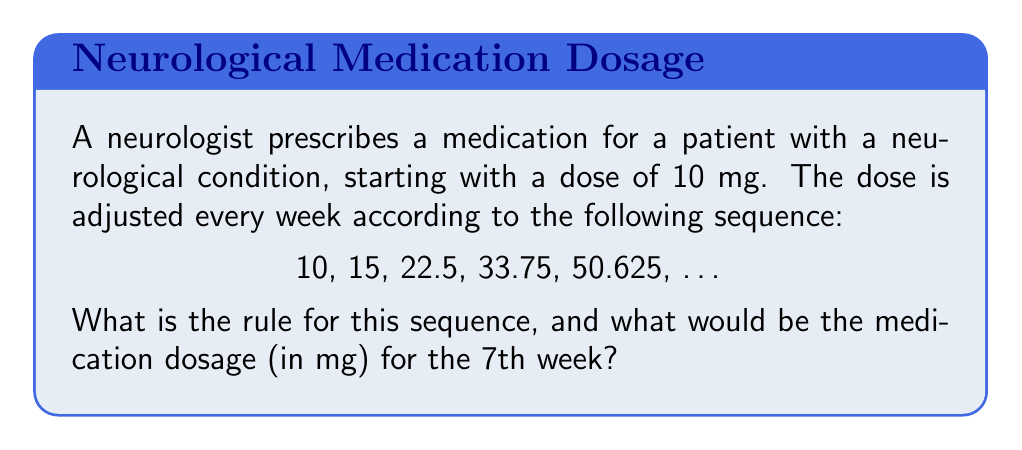What is the answer to this math problem? To identify the rule for this sequence and determine the 7th week's dosage, let's follow these steps:

1. Observe the pattern between consecutive terms:
   $\frac{15}{10} = 1.5$
   $\frac{22.5}{15} = 1.5$
   $\frac{33.75}{22.5} = 1.5$
   $\frac{50.625}{33.75} = 1.5$

2. We can see that each term is multiplied by 1.5 to get the next term.

3. The rule for this sequence can be expressed as:
   $a_n = a_1 \times 1.5^{n-1}$
   Where $a_n$ is the nth term, and $a_1 = 10$ (the initial dose).

4. To find the 7th week's dosage:
   $a_7 = 10 \times 1.5^{7-1}$
   $a_7 = 10 \times 1.5^6$

5. Calculate:
   $a_7 = 10 \times (1.5^6)$
   $a_7 = 10 \times 11.390625$
   $a_7 = 113.90625$ mg

Therefore, the dosage for the 7th week would be 113.90625 mg.
Answer: Rule: $a_n = 10 \times 1.5^{n-1}$; 7th week dosage: 113.90625 mg 